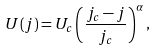Convert formula to latex. <formula><loc_0><loc_0><loc_500><loc_500>U ( j ) = U _ { c } \left ( \frac { j _ { c } - j } { j _ { c } } \right ) ^ { \alpha } ,</formula> 